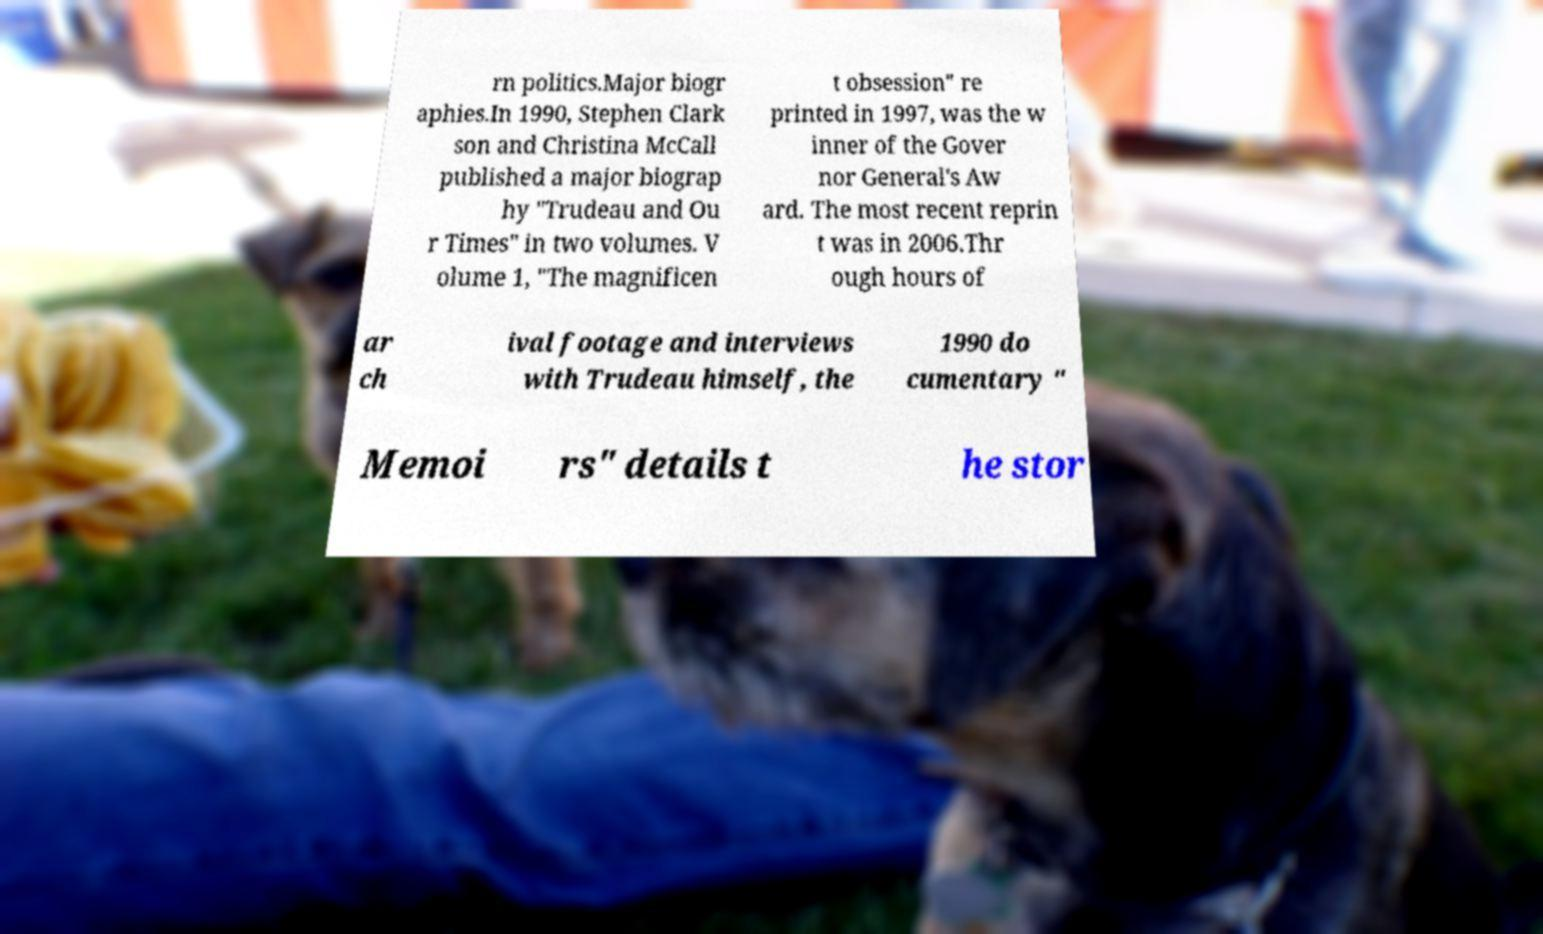What messages or text are displayed in this image? I need them in a readable, typed format. rn politics.Major biogr aphies.In 1990, Stephen Clark son and Christina McCall published a major biograp hy "Trudeau and Ou r Times" in two volumes. V olume 1, "The magnificen t obsession" re printed in 1997, was the w inner of the Gover nor General's Aw ard. The most recent reprin t was in 2006.Thr ough hours of ar ch ival footage and interviews with Trudeau himself, the 1990 do cumentary " Memoi rs" details t he stor 